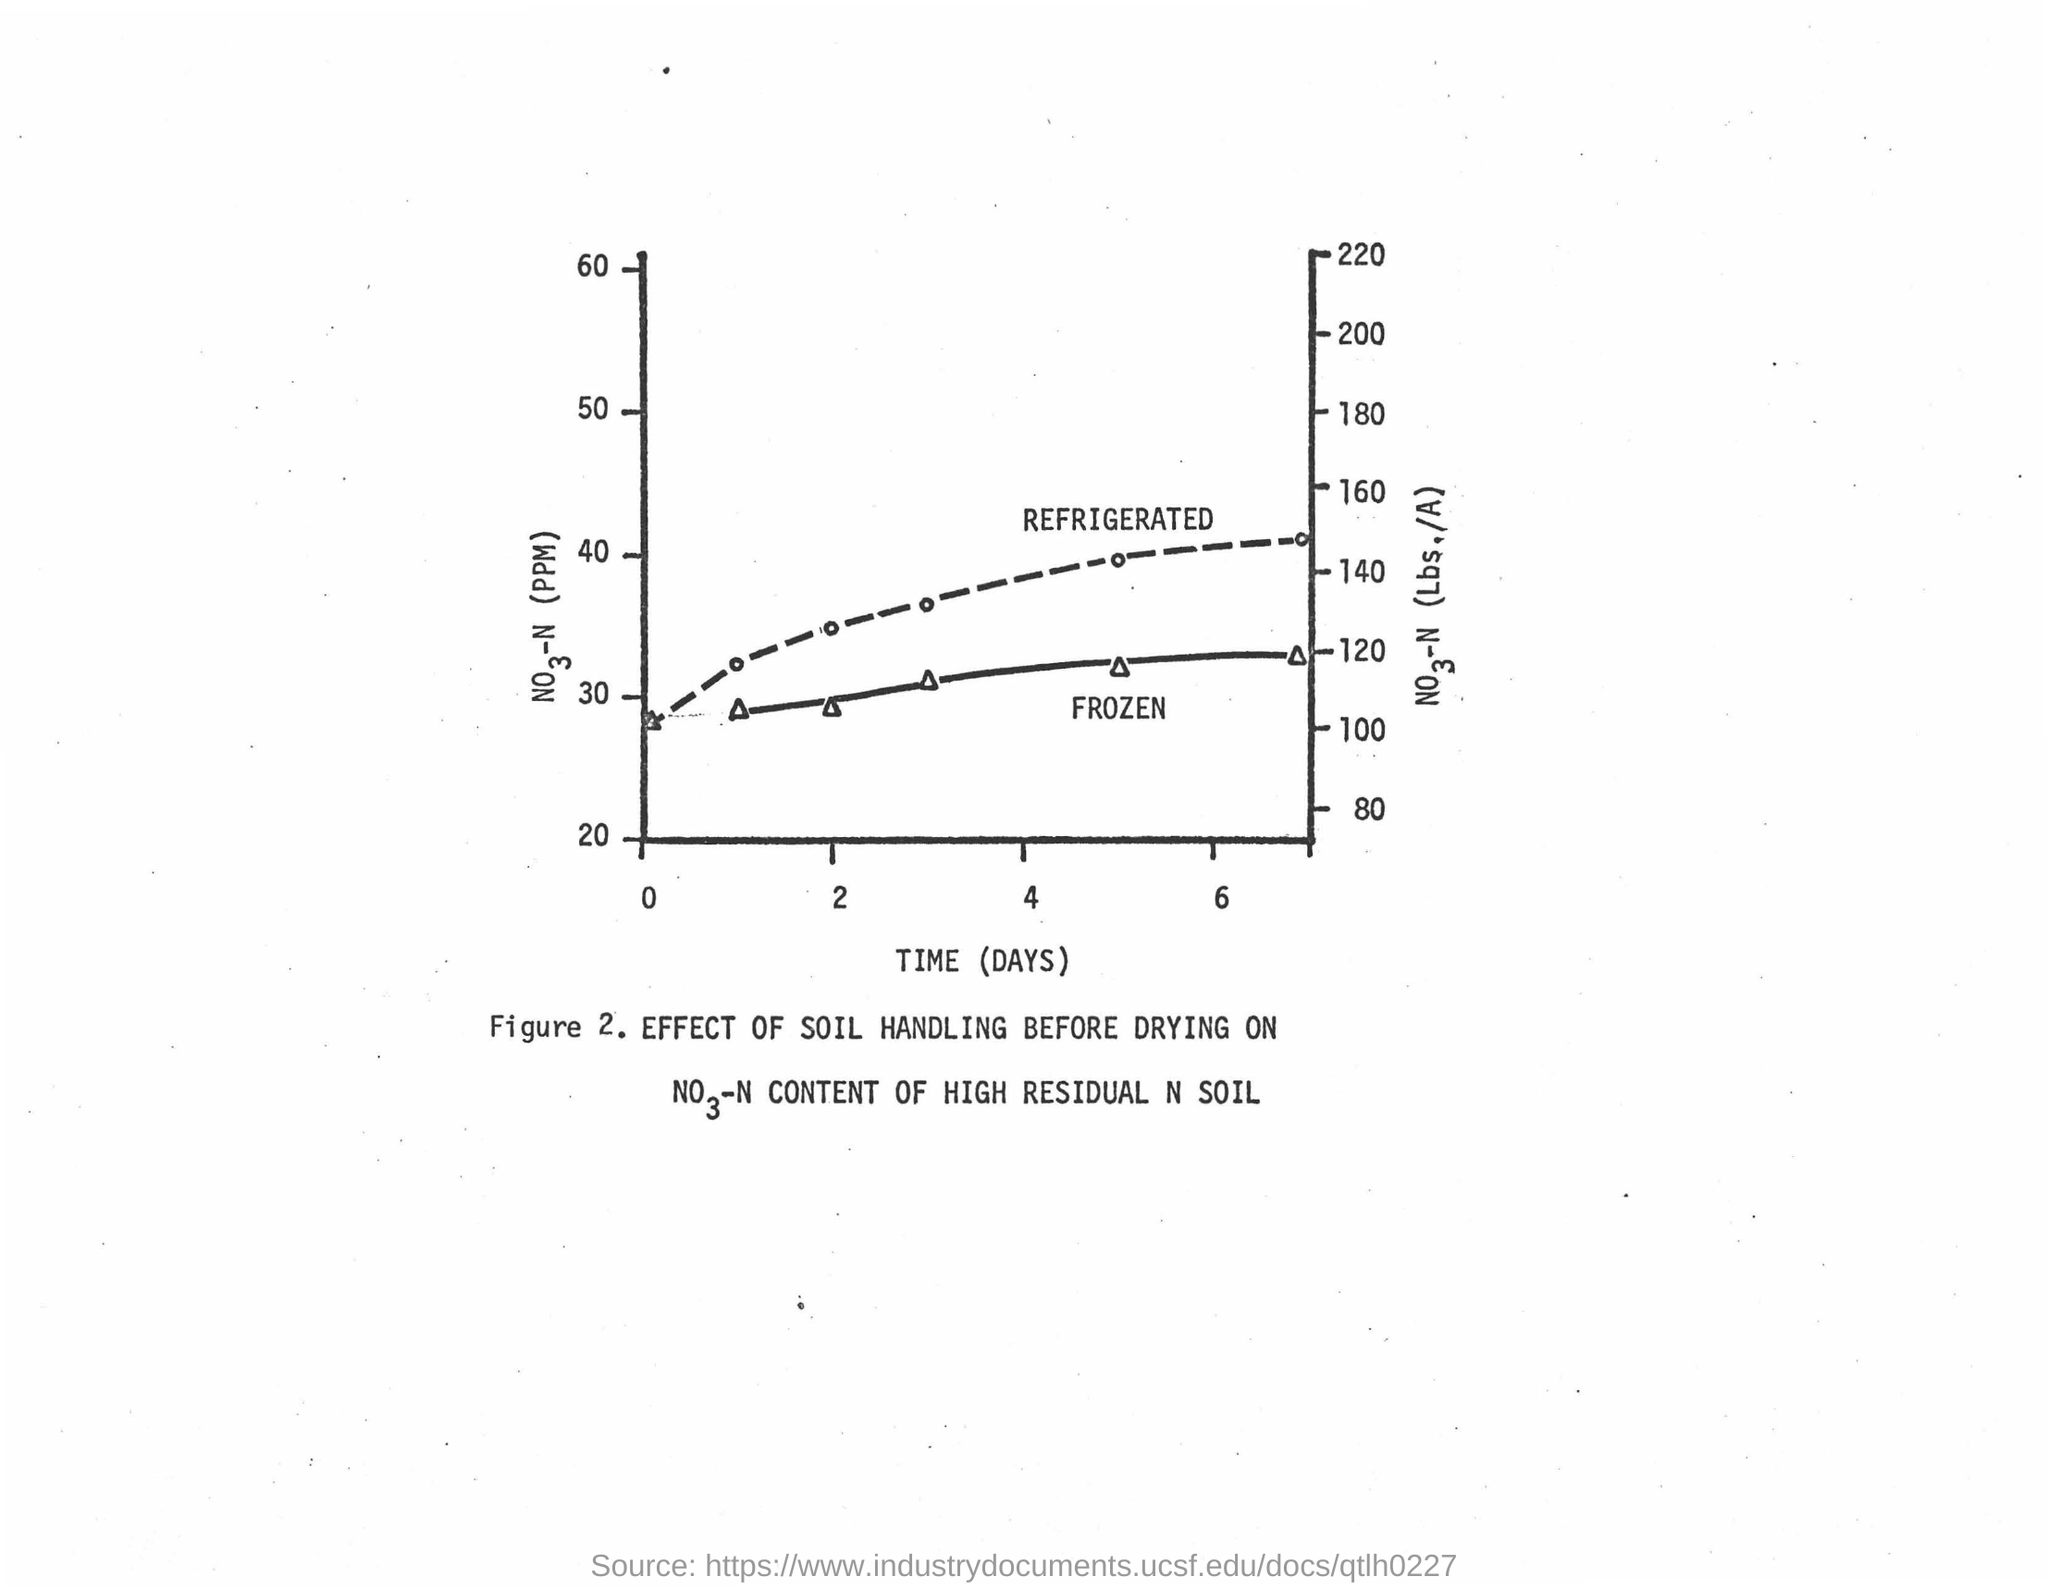Mention a couple of crucial points in this snapshot. The x-axis in the plot displays time (days). 